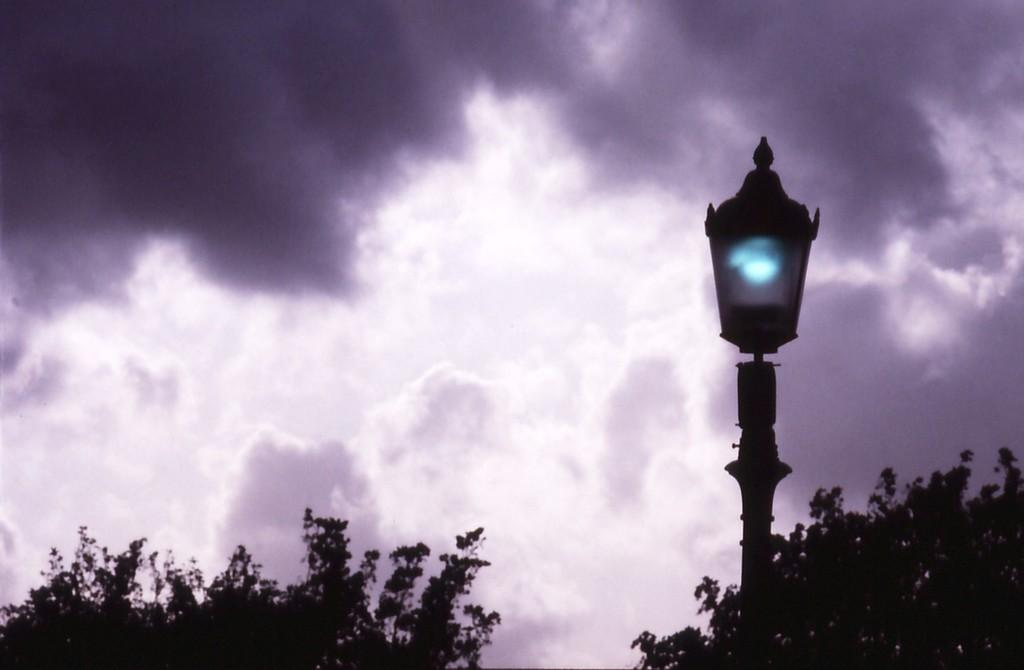What can be seen in the sky in the image? There are clouds in the sky in the image. What type of vegetation is present at the bottom of the image? There are trees at the bottom of the image. What structure is located in the middle of the image? There is a pole with a light in the middle of the image. What color of paint is used on the trees in the image? There is no indication that the trees have been painted in the image, so we cannot determine the color of paint used. How does the light on the pole affect the amusement of the people in the image? There are no people present in the image, so we cannot determine how the light on the pole affects their amusement. 